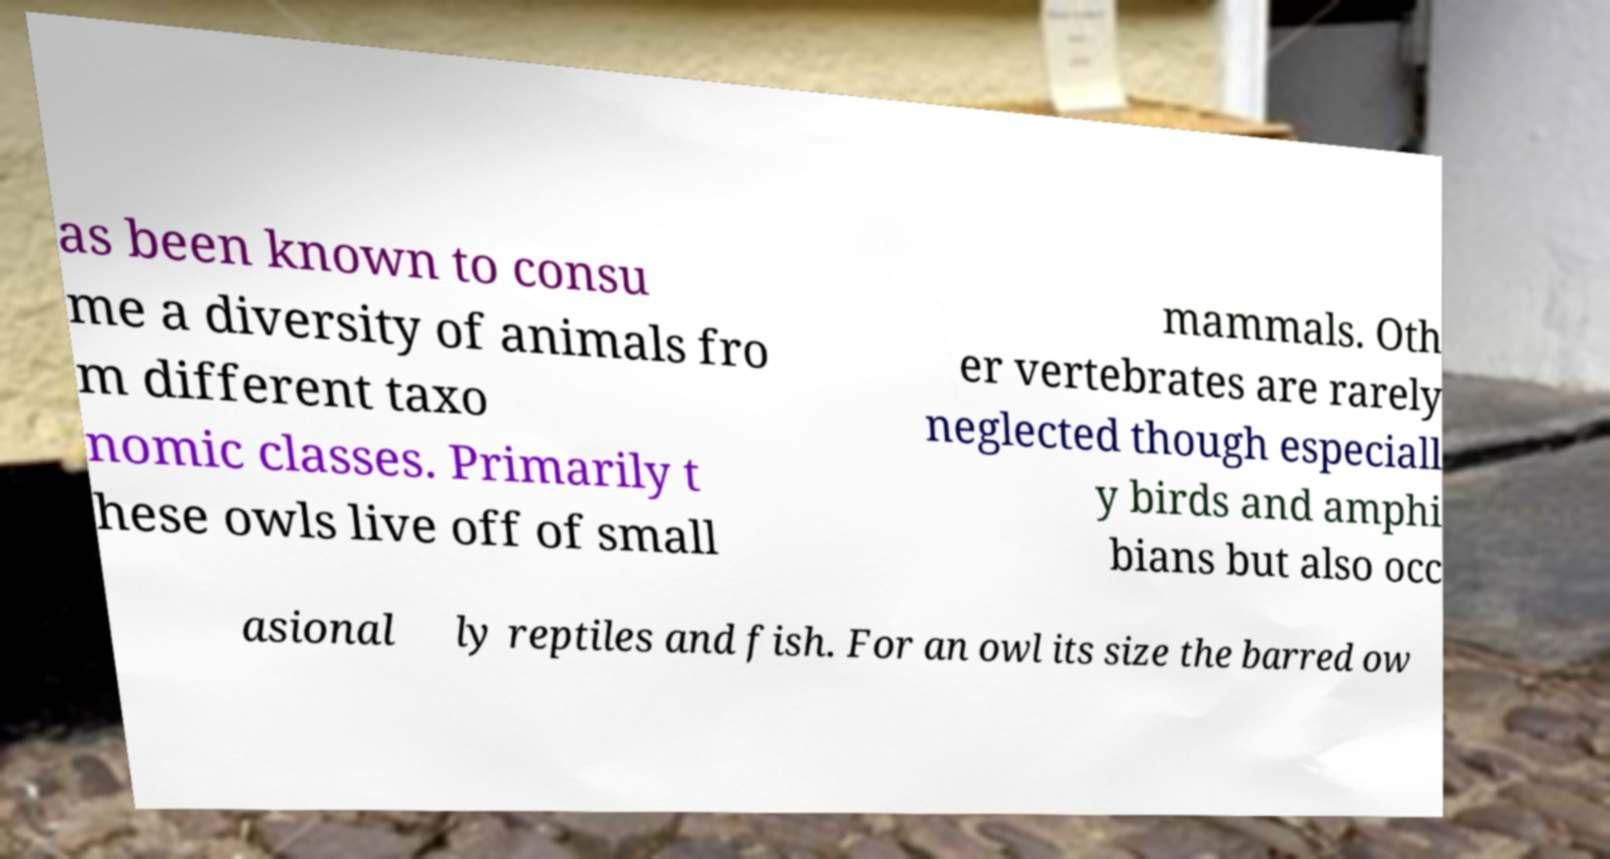Could you assist in decoding the text presented in this image and type it out clearly? as been known to consu me a diversity of animals fro m different taxo nomic classes. Primarily t hese owls live off of small mammals. Oth er vertebrates are rarely neglected though especiall y birds and amphi bians but also occ asional ly reptiles and fish. For an owl its size the barred ow 